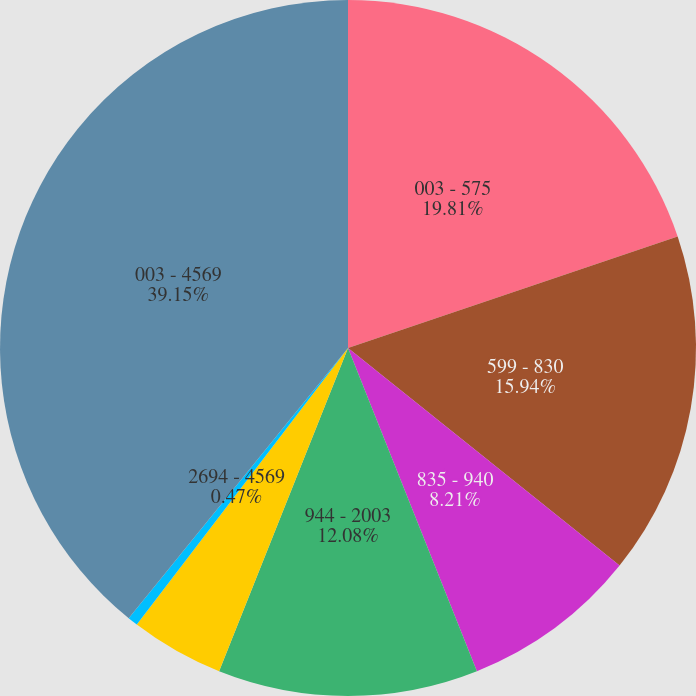Convert chart. <chart><loc_0><loc_0><loc_500><loc_500><pie_chart><fcel>003 - 575<fcel>599 - 830<fcel>835 - 940<fcel>944 - 2003<fcel>2097 - 2692<fcel>2694 - 4569<fcel>003 - 4569<nl><fcel>19.81%<fcel>15.94%<fcel>8.21%<fcel>12.08%<fcel>4.34%<fcel>0.47%<fcel>39.15%<nl></chart> 